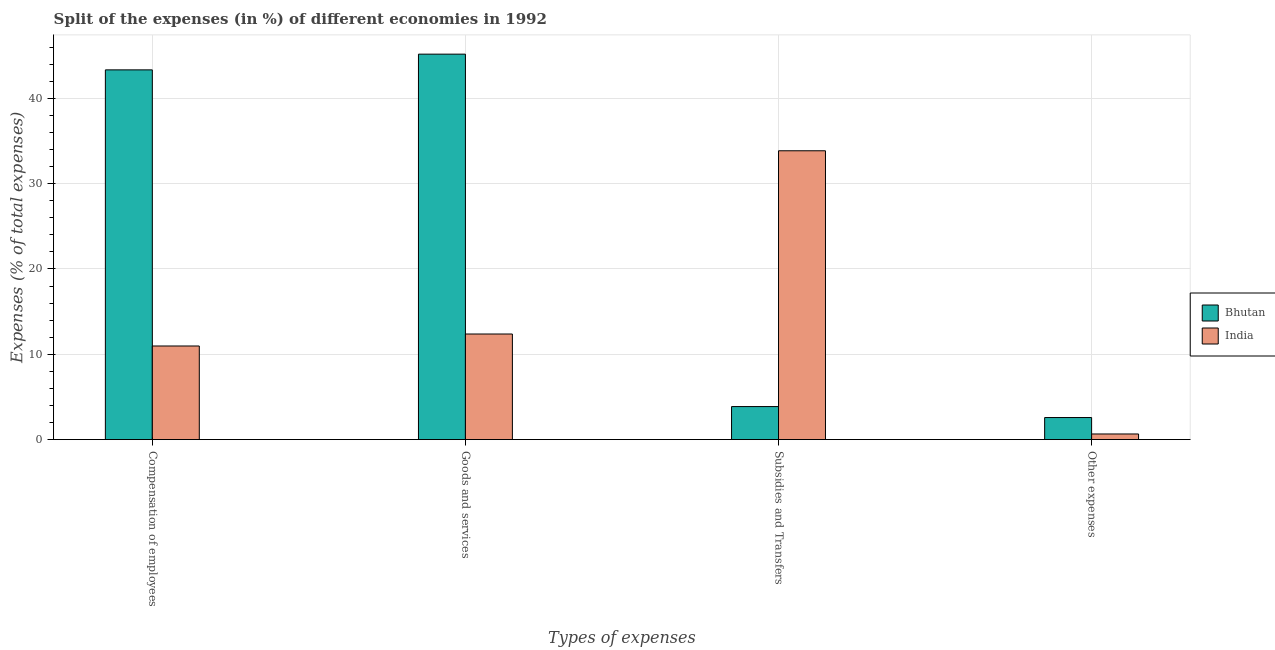How many groups of bars are there?
Keep it short and to the point. 4. How many bars are there on the 4th tick from the left?
Your answer should be compact. 2. How many bars are there on the 4th tick from the right?
Ensure brevity in your answer.  2. What is the label of the 3rd group of bars from the left?
Your answer should be very brief. Subsidies and Transfers. What is the percentage of amount spent on subsidies in India?
Give a very brief answer. 33.85. Across all countries, what is the maximum percentage of amount spent on subsidies?
Provide a succinct answer. 33.85. Across all countries, what is the minimum percentage of amount spent on other expenses?
Keep it short and to the point. 0.66. In which country was the percentage of amount spent on goods and services maximum?
Make the answer very short. Bhutan. What is the total percentage of amount spent on goods and services in the graph?
Your answer should be very brief. 57.55. What is the difference between the percentage of amount spent on subsidies in India and that in Bhutan?
Ensure brevity in your answer.  29.98. What is the difference between the percentage of amount spent on other expenses in India and the percentage of amount spent on compensation of employees in Bhutan?
Offer a terse response. -42.67. What is the average percentage of amount spent on goods and services per country?
Your answer should be compact. 28.78. What is the difference between the percentage of amount spent on goods and services and percentage of amount spent on subsidies in India?
Ensure brevity in your answer.  -21.48. In how many countries, is the percentage of amount spent on compensation of employees greater than 30 %?
Make the answer very short. 1. What is the ratio of the percentage of amount spent on other expenses in Bhutan to that in India?
Your answer should be very brief. 3.92. What is the difference between the highest and the second highest percentage of amount spent on goods and services?
Make the answer very short. 32.8. What is the difference between the highest and the lowest percentage of amount spent on subsidies?
Your answer should be very brief. 29.98. In how many countries, is the percentage of amount spent on subsidies greater than the average percentage of amount spent on subsidies taken over all countries?
Offer a very short reply. 1. Is it the case that in every country, the sum of the percentage of amount spent on other expenses and percentage of amount spent on compensation of employees is greater than the sum of percentage of amount spent on goods and services and percentage of amount spent on subsidies?
Your answer should be very brief. No. What does the 2nd bar from the right in Compensation of employees represents?
Your answer should be very brief. Bhutan. Is it the case that in every country, the sum of the percentage of amount spent on compensation of employees and percentage of amount spent on goods and services is greater than the percentage of amount spent on subsidies?
Your response must be concise. No. What is the difference between two consecutive major ticks on the Y-axis?
Give a very brief answer. 10. Does the graph contain grids?
Ensure brevity in your answer.  Yes. How are the legend labels stacked?
Offer a terse response. Vertical. What is the title of the graph?
Your answer should be very brief. Split of the expenses (in %) of different economies in 1992. What is the label or title of the X-axis?
Give a very brief answer. Types of expenses. What is the label or title of the Y-axis?
Make the answer very short. Expenses (% of total expenses). What is the Expenses (% of total expenses) of Bhutan in Compensation of employees?
Provide a short and direct response. 43.33. What is the Expenses (% of total expenses) of India in Compensation of employees?
Provide a short and direct response. 10.97. What is the Expenses (% of total expenses) of Bhutan in Goods and services?
Ensure brevity in your answer.  45.18. What is the Expenses (% of total expenses) in India in Goods and services?
Make the answer very short. 12.38. What is the Expenses (% of total expenses) in Bhutan in Subsidies and Transfers?
Your answer should be very brief. 3.87. What is the Expenses (% of total expenses) of India in Subsidies and Transfers?
Make the answer very short. 33.85. What is the Expenses (% of total expenses) in Bhutan in Other expenses?
Offer a terse response. 2.59. What is the Expenses (% of total expenses) in India in Other expenses?
Your answer should be compact. 0.66. Across all Types of expenses, what is the maximum Expenses (% of total expenses) of Bhutan?
Give a very brief answer. 45.18. Across all Types of expenses, what is the maximum Expenses (% of total expenses) in India?
Your answer should be compact. 33.85. Across all Types of expenses, what is the minimum Expenses (% of total expenses) of Bhutan?
Make the answer very short. 2.59. Across all Types of expenses, what is the minimum Expenses (% of total expenses) of India?
Ensure brevity in your answer.  0.66. What is the total Expenses (% of total expenses) in Bhutan in the graph?
Keep it short and to the point. 94.97. What is the total Expenses (% of total expenses) in India in the graph?
Your response must be concise. 57.86. What is the difference between the Expenses (% of total expenses) of Bhutan in Compensation of employees and that in Goods and services?
Make the answer very short. -1.84. What is the difference between the Expenses (% of total expenses) of India in Compensation of employees and that in Goods and services?
Keep it short and to the point. -1.41. What is the difference between the Expenses (% of total expenses) in Bhutan in Compensation of employees and that in Subsidies and Transfers?
Provide a succinct answer. 39.46. What is the difference between the Expenses (% of total expenses) in India in Compensation of employees and that in Subsidies and Transfers?
Ensure brevity in your answer.  -22.88. What is the difference between the Expenses (% of total expenses) in Bhutan in Compensation of employees and that in Other expenses?
Keep it short and to the point. 40.75. What is the difference between the Expenses (% of total expenses) in India in Compensation of employees and that in Other expenses?
Ensure brevity in your answer.  10.31. What is the difference between the Expenses (% of total expenses) in Bhutan in Goods and services and that in Subsidies and Transfers?
Your answer should be compact. 41.31. What is the difference between the Expenses (% of total expenses) in India in Goods and services and that in Subsidies and Transfers?
Give a very brief answer. -21.48. What is the difference between the Expenses (% of total expenses) in Bhutan in Goods and services and that in Other expenses?
Provide a short and direct response. 42.59. What is the difference between the Expenses (% of total expenses) of India in Goods and services and that in Other expenses?
Offer a terse response. 11.72. What is the difference between the Expenses (% of total expenses) of Bhutan in Subsidies and Transfers and that in Other expenses?
Provide a succinct answer. 1.28. What is the difference between the Expenses (% of total expenses) of India in Subsidies and Transfers and that in Other expenses?
Keep it short and to the point. 33.19. What is the difference between the Expenses (% of total expenses) of Bhutan in Compensation of employees and the Expenses (% of total expenses) of India in Goods and services?
Provide a succinct answer. 30.96. What is the difference between the Expenses (% of total expenses) of Bhutan in Compensation of employees and the Expenses (% of total expenses) of India in Subsidies and Transfers?
Keep it short and to the point. 9.48. What is the difference between the Expenses (% of total expenses) of Bhutan in Compensation of employees and the Expenses (% of total expenses) of India in Other expenses?
Make the answer very short. 42.67. What is the difference between the Expenses (% of total expenses) in Bhutan in Goods and services and the Expenses (% of total expenses) in India in Subsidies and Transfers?
Keep it short and to the point. 11.32. What is the difference between the Expenses (% of total expenses) of Bhutan in Goods and services and the Expenses (% of total expenses) of India in Other expenses?
Offer a terse response. 44.52. What is the difference between the Expenses (% of total expenses) in Bhutan in Subsidies and Transfers and the Expenses (% of total expenses) in India in Other expenses?
Your answer should be compact. 3.21. What is the average Expenses (% of total expenses) in Bhutan per Types of expenses?
Keep it short and to the point. 23.74. What is the average Expenses (% of total expenses) of India per Types of expenses?
Make the answer very short. 14.47. What is the difference between the Expenses (% of total expenses) in Bhutan and Expenses (% of total expenses) in India in Compensation of employees?
Offer a very short reply. 32.36. What is the difference between the Expenses (% of total expenses) of Bhutan and Expenses (% of total expenses) of India in Goods and services?
Offer a terse response. 32.8. What is the difference between the Expenses (% of total expenses) of Bhutan and Expenses (% of total expenses) of India in Subsidies and Transfers?
Your response must be concise. -29.98. What is the difference between the Expenses (% of total expenses) of Bhutan and Expenses (% of total expenses) of India in Other expenses?
Keep it short and to the point. 1.93. What is the ratio of the Expenses (% of total expenses) of Bhutan in Compensation of employees to that in Goods and services?
Your answer should be very brief. 0.96. What is the ratio of the Expenses (% of total expenses) of India in Compensation of employees to that in Goods and services?
Keep it short and to the point. 0.89. What is the ratio of the Expenses (% of total expenses) in Bhutan in Compensation of employees to that in Subsidies and Transfers?
Keep it short and to the point. 11.19. What is the ratio of the Expenses (% of total expenses) of India in Compensation of employees to that in Subsidies and Transfers?
Make the answer very short. 0.32. What is the ratio of the Expenses (% of total expenses) in Bhutan in Compensation of employees to that in Other expenses?
Your answer should be compact. 16.75. What is the ratio of the Expenses (% of total expenses) in India in Compensation of employees to that in Other expenses?
Your answer should be very brief. 16.61. What is the ratio of the Expenses (% of total expenses) in Bhutan in Goods and services to that in Subsidies and Transfers?
Ensure brevity in your answer.  11.67. What is the ratio of the Expenses (% of total expenses) in India in Goods and services to that in Subsidies and Transfers?
Your response must be concise. 0.37. What is the ratio of the Expenses (% of total expenses) in Bhutan in Goods and services to that in Other expenses?
Your answer should be compact. 17.46. What is the ratio of the Expenses (% of total expenses) in India in Goods and services to that in Other expenses?
Make the answer very short. 18.74. What is the ratio of the Expenses (% of total expenses) of Bhutan in Subsidies and Transfers to that in Other expenses?
Your answer should be compact. 1.5. What is the ratio of the Expenses (% of total expenses) in India in Subsidies and Transfers to that in Other expenses?
Your answer should be very brief. 51.25. What is the difference between the highest and the second highest Expenses (% of total expenses) in Bhutan?
Your answer should be very brief. 1.84. What is the difference between the highest and the second highest Expenses (% of total expenses) of India?
Offer a very short reply. 21.48. What is the difference between the highest and the lowest Expenses (% of total expenses) of Bhutan?
Offer a very short reply. 42.59. What is the difference between the highest and the lowest Expenses (% of total expenses) in India?
Your answer should be very brief. 33.19. 